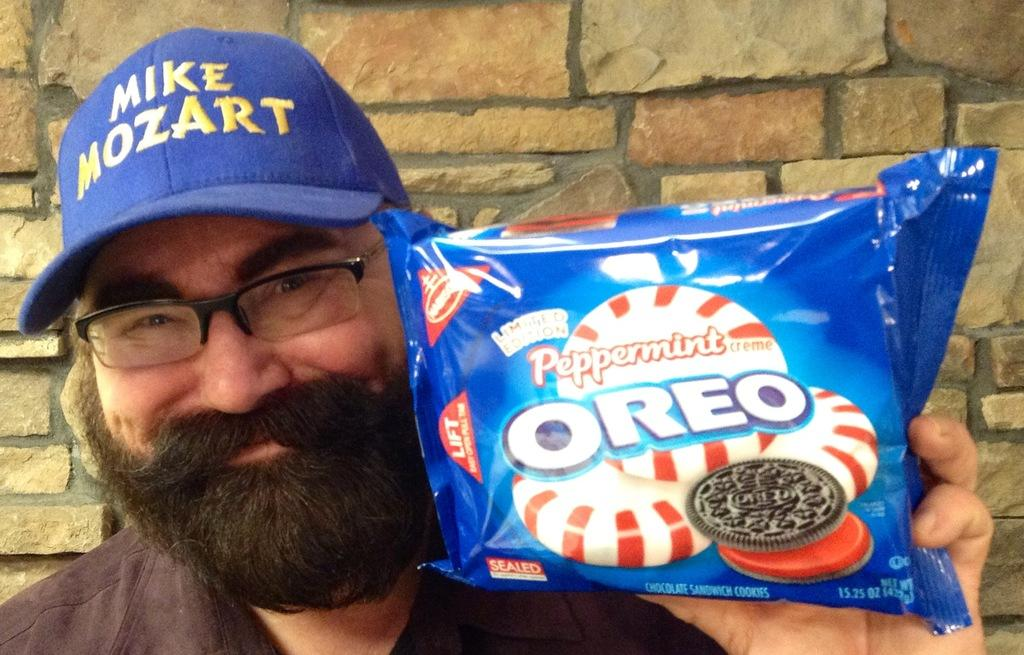Who is present in the image? There is a man in the image. What is the man holding in his hand? The man is holding an Oreo biscuit packet in his hand. What type of headwear is the man wearing? The man is wearing a cap. What can be seen in the background of the image? There is a wall in the background of the image. What song is the man singing in the image? There is no indication in the image that the man is singing, and therefore no song can be identified. 